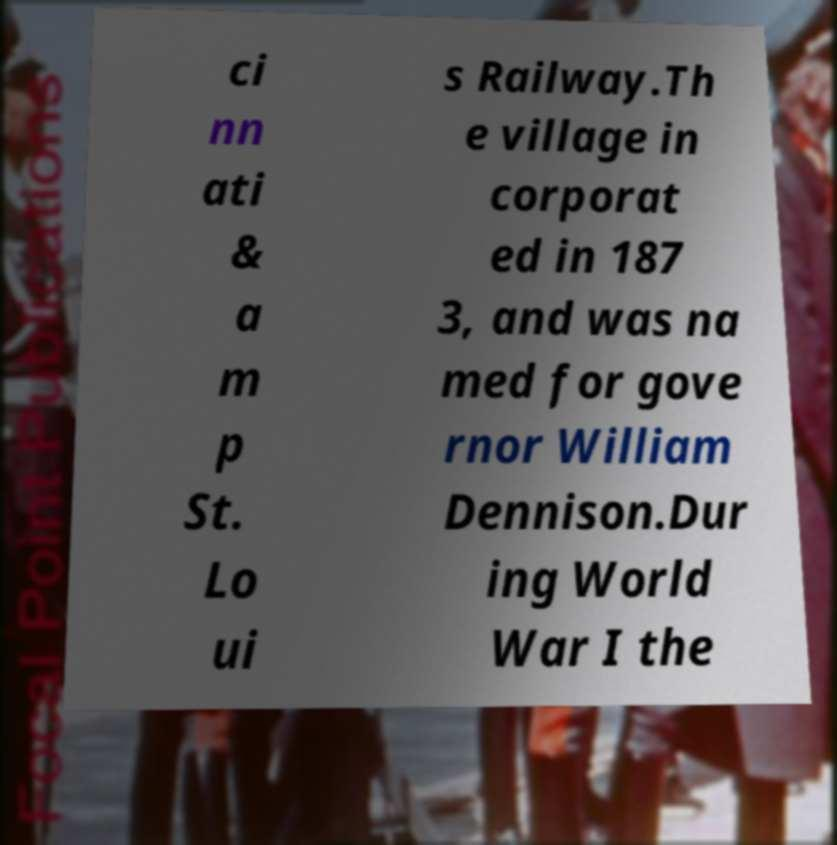Can you accurately transcribe the text from the provided image for me? ci nn ati & a m p St. Lo ui s Railway.Th e village in corporat ed in 187 3, and was na med for gove rnor William Dennison.Dur ing World War I the 